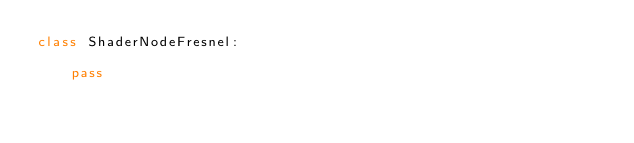<code> <loc_0><loc_0><loc_500><loc_500><_Python_>class ShaderNodeFresnel:

    pass


</code> 